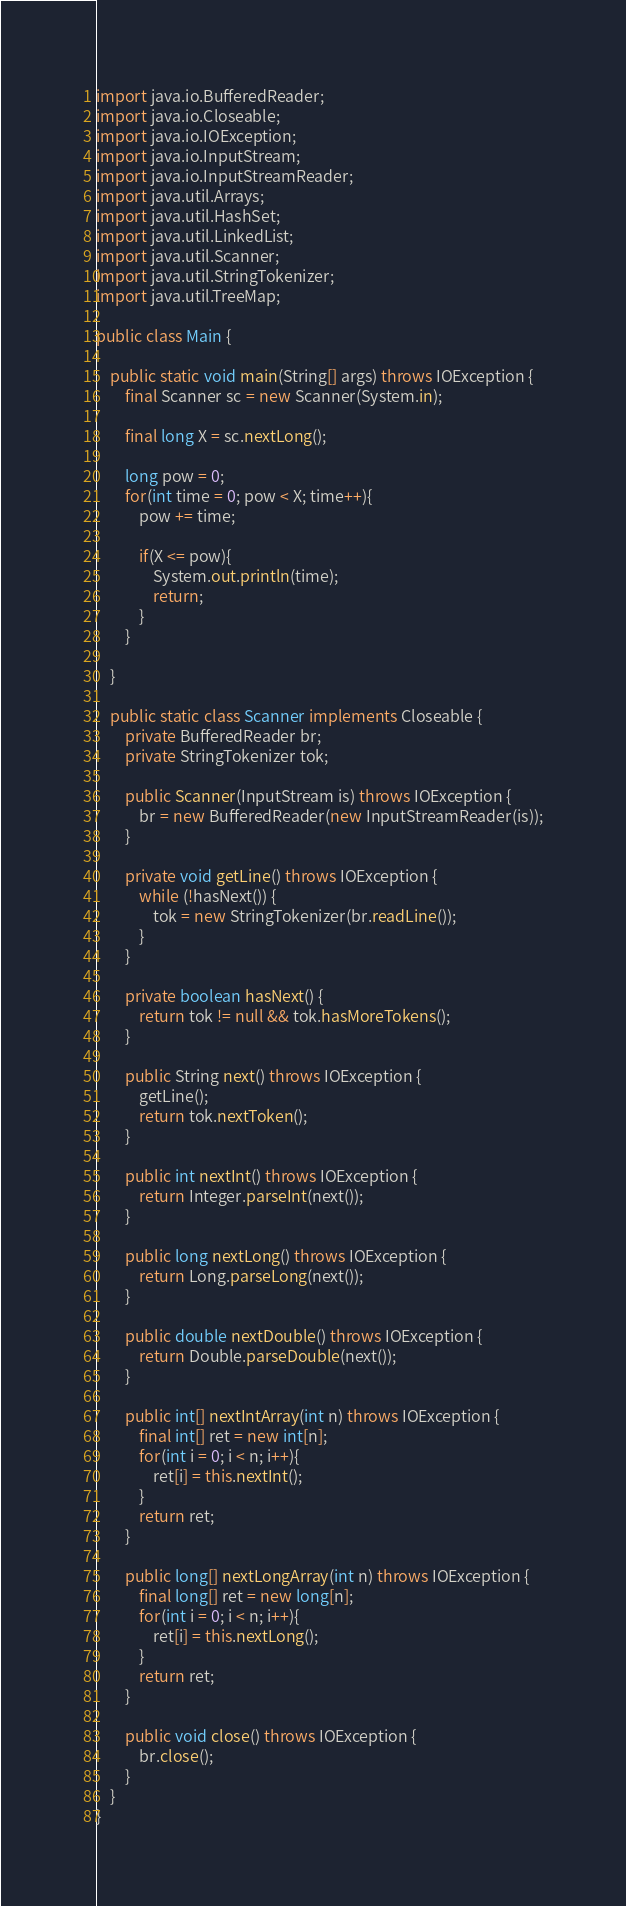<code> <loc_0><loc_0><loc_500><loc_500><_Java_>import java.io.BufferedReader;
import java.io.Closeable;
import java.io.IOException;
import java.io.InputStream;
import java.io.InputStreamReader;
import java.util.Arrays;
import java.util.HashSet;
import java.util.LinkedList;
import java.util.Scanner;
import java.util.StringTokenizer;
import java.util.TreeMap;

public class Main {
	
	public static void main(String[] args) throws IOException {
		final Scanner sc = new Scanner(System.in);
		
		final long X = sc.nextLong();
		
		long pow = 0;
		for(int time = 0; pow < X; time++){
			pow += time;
			
			if(X <= pow){
				System.out.println(time);
				return;
			}
		}
		
	}
	
	public static class Scanner implements Closeable {
		private BufferedReader br;
		private StringTokenizer tok;
 
		public Scanner(InputStream is) throws IOException {
			br = new BufferedReader(new InputStreamReader(is));
		}
 
		private void getLine() throws IOException {
			while (!hasNext()) {
				tok = new StringTokenizer(br.readLine());
			}
		}
 
		private boolean hasNext() {
			return tok != null && tok.hasMoreTokens();
		}
 
		public String next() throws IOException {
			getLine();
			return tok.nextToken();
		}
 
		public int nextInt() throws IOException {
			return Integer.parseInt(next());
		}
 
		public long nextLong() throws IOException {
			return Long.parseLong(next());
		}
 
		public double nextDouble() throws IOException {
			return Double.parseDouble(next());
		}
		
		public int[] nextIntArray(int n) throws IOException {
			final int[] ret = new int[n];
			for(int i = 0; i < n; i++){
				ret[i] = this.nextInt();
			}
			return ret;
		}
		
		public long[] nextLongArray(int n) throws IOException {
			final long[] ret = new long[n];
			for(int i = 0; i < n; i++){
				ret[i] = this.nextLong();
			}
			return ret;
		}
 
		public void close() throws IOException {
			br.close();
		}
	}
}</code> 